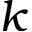Convert formula to latex. <formula><loc_0><loc_0><loc_500><loc_500>k</formula> 